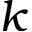Convert formula to latex. <formula><loc_0><loc_0><loc_500><loc_500>k</formula> 